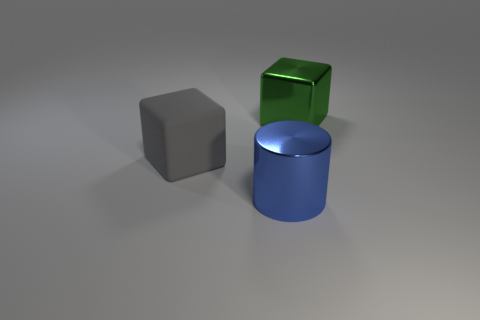How could these objects be used to explain geometry? These objects provide a great opportunity to discuss geometric shapes and their properties. The cube can illustrate concepts like edges, vertices, and faces; the cylinder can be used to talk about curved surfaces and circular bases; and these comparisons can lead to discussing the differences between prisms and non-prismatic shapes. 